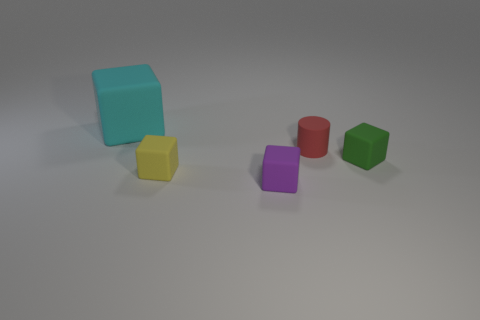The red thing that is the same size as the yellow matte block is what shape?
Offer a very short reply. Cylinder. Is there a small green thing that has the same shape as the cyan matte object?
Your answer should be compact. Yes. Is the purple thing made of the same material as the small cube to the right of the red thing?
Give a very brief answer. Yes. There is a cube that is right of the tiny rubber thing that is in front of the tiny yellow matte cube; what is its material?
Provide a succinct answer. Rubber. Is the number of yellow cubes to the left of the yellow rubber object greater than the number of small purple objects?
Your answer should be very brief. No. Is there a red object?
Give a very brief answer. Yes. There is a tiny object behind the green rubber cube; what color is it?
Offer a very short reply. Red. What material is the cylinder that is the same size as the purple matte thing?
Your answer should be compact. Rubber. How many other objects are there of the same material as the yellow object?
Offer a terse response. 4. The block that is both behind the tiny purple matte cube and right of the yellow block is what color?
Provide a succinct answer. Green. 